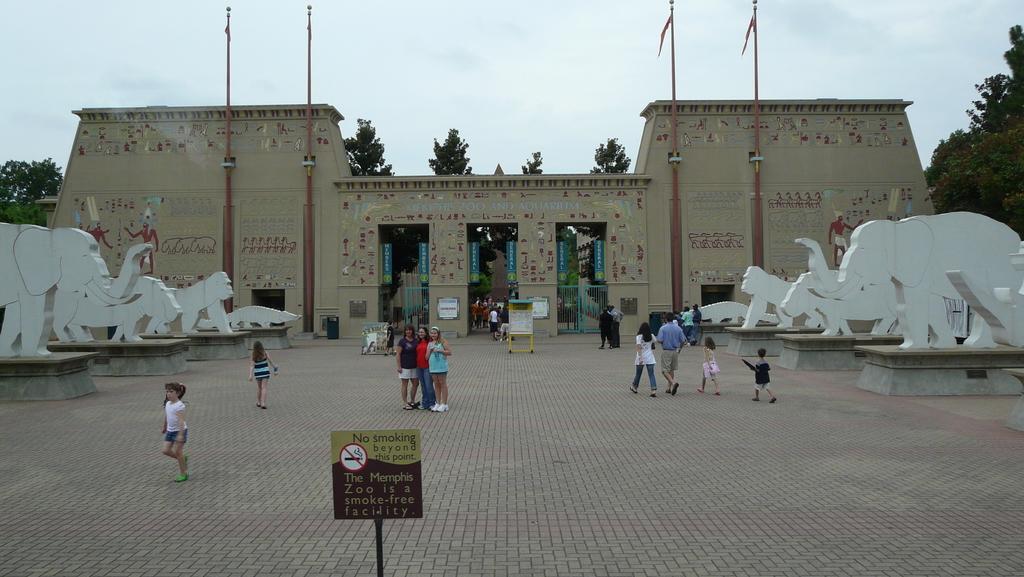Can you describe this image briefly? On the left side of the image we can see an elephant statue and some other animal statues and trees. In the middle of the image we can see some people are standing and some of them are walking, a no smoking board is there and entrance of the arch is there. On the right side of the image we can see some statues of animals and flags. 